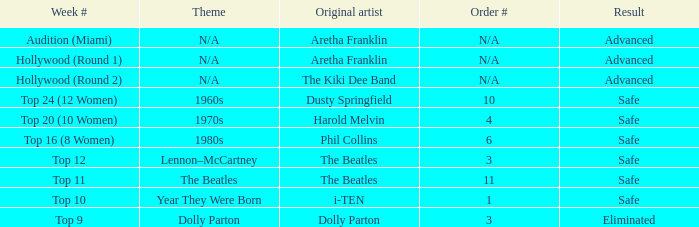What is the order number that has Aretha Franklin as the original artist? N/A, N/A. 